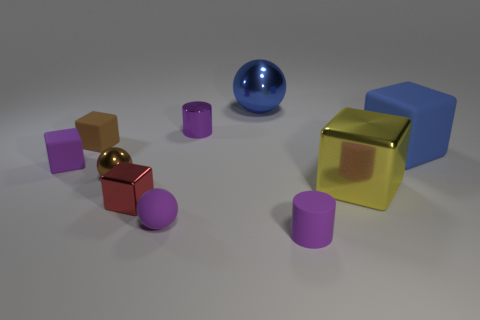Subtract all blue rubber cubes. How many cubes are left? 4 Subtract all red cubes. How many cubes are left? 4 Subtract all cylinders. How many objects are left? 8 Subtract all large spheres. Subtract all yellow blocks. How many objects are left? 8 Add 8 blue blocks. How many blue blocks are left? 9 Add 6 red blocks. How many red blocks exist? 7 Subtract 0 red cylinders. How many objects are left? 10 Subtract all yellow cylinders. Subtract all blue balls. How many cylinders are left? 2 